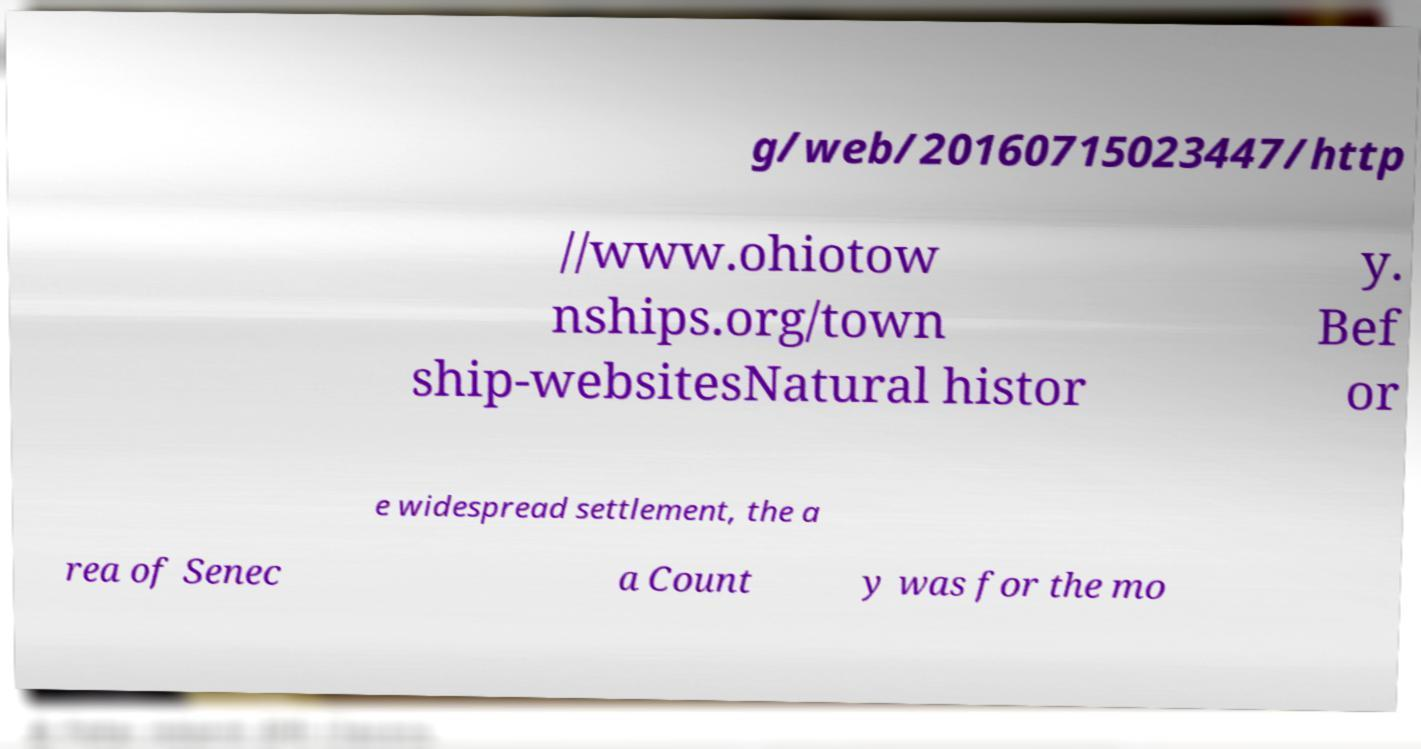I need the written content from this picture converted into text. Can you do that? g/web/20160715023447/http //www.ohiotow nships.org/town ship-websitesNatural histor y. Bef or e widespread settlement, the a rea of Senec a Count y was for the mo 